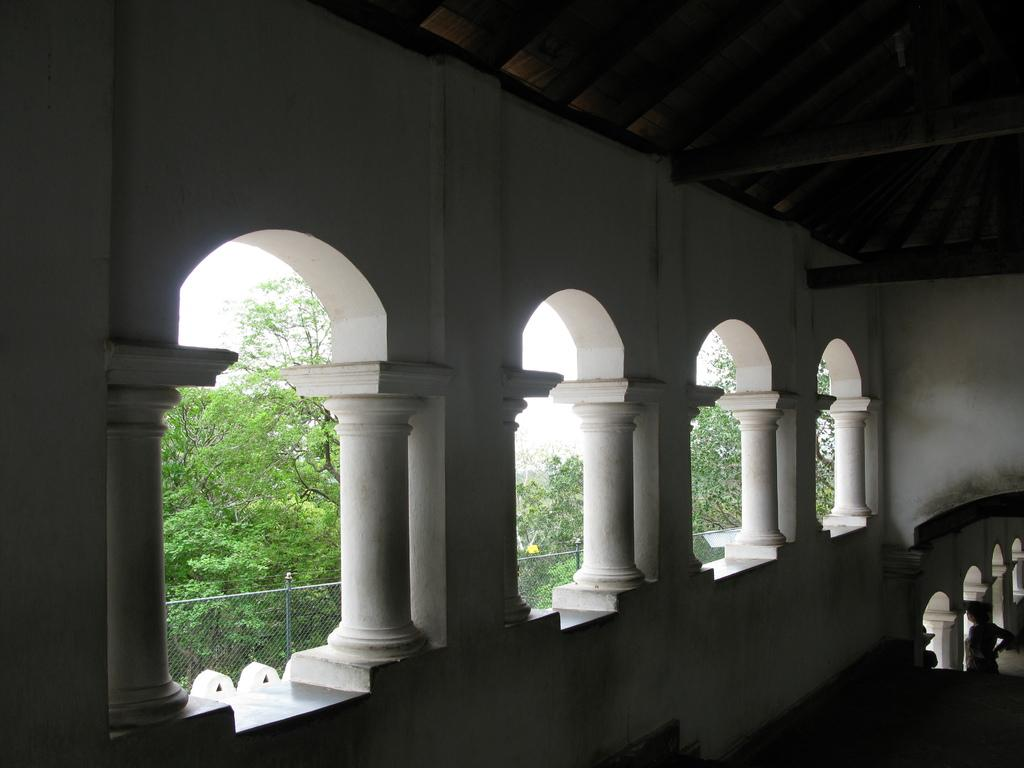What type of structure is depicted in the image? There is a building with pillars in the image. What can be seen behind the building? There is a group of trees on the backside of the building. What is the purpose of the barrier visible in the image? There is a fence visible in the image, which may serve as a boundary or barrier. What is visible in the background of the image? The sky is visible in the image. Can you describe the person in the image? There is a person standing on the right side of the image. What type of crate is being used to transport the person's lunch in the image? There is no crate or lunch present in the image. 